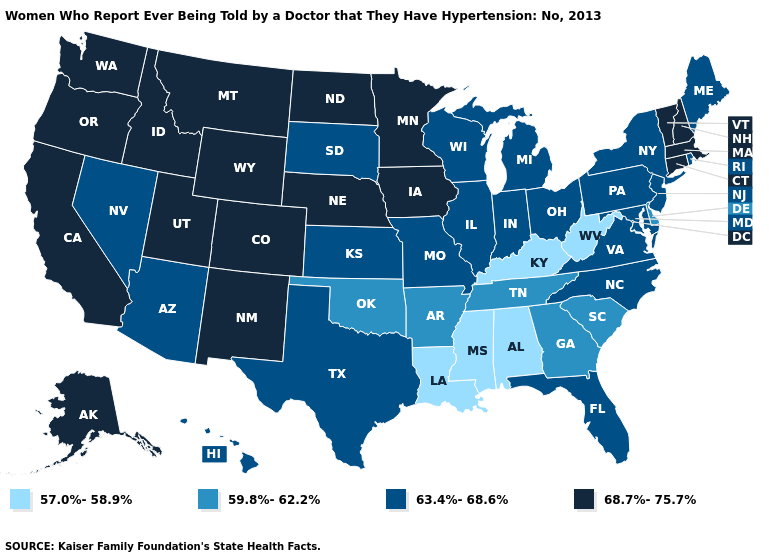Name the states that have a value in the range 68.7%-75.7%?
Keep it brief. Alaska, California, Colorado, Connecticut, Idaho, Iowa, Massachusetts, Minnesota, Montana, Nebraska, New Hampshire, New Mexico, North Dakota, Oregon, Utah, Vermont, Washington, Wyoming. Does the first symbol in the legend represent the smallest category?
Give a very brief answer. Yes. Among the states that border New York , does Vermont have the highest value?
Concise answer only. Yes. Is the legend a continuous bar?
Be succinct. No. Does the map have missing data?
Write a very short answer. No. Among the states that border North Carolina , does South Carolina have the lowest value?
Quick response, please. Yes. What is the value of Connecticut?
Keep it brief. 68.7%-75.7%. What is the highest value in states that border Vermont?
Answer briefly. 68.7%-75.7%. Does the first symbol in the legend represent the smallest category?
Give a very brief answer. Yes. Name the states that have a value in the range 63.4%-68.6%?
Quick response, please. Arizona, Florida, Hawaii, Illinois, Indiana, Kansas, Maine, Maryland, Michigan, Missouri, Nevada, New Jersey, New York, North Carolina, Ohio, Pennsylvania, Rhode Island, South Dakota, Texas, Virginia, Wisconsin. Does the map have missing data?
Keep it brief. No. Name the states that have a value in the range 57.0%-58.9%?
Concise answer only. Alabama, Kentucky, Louisiana, Mississippi, West Virginia. Among the states that border Kentucky , does Virginia have the lowest value?
Answer briefly. No. Does West Virginia have the same value as Alabama?
Be succinct. Yes. Among the states that border Kentucky , which have the lowest value?
Keep it brief. West Virginia. 